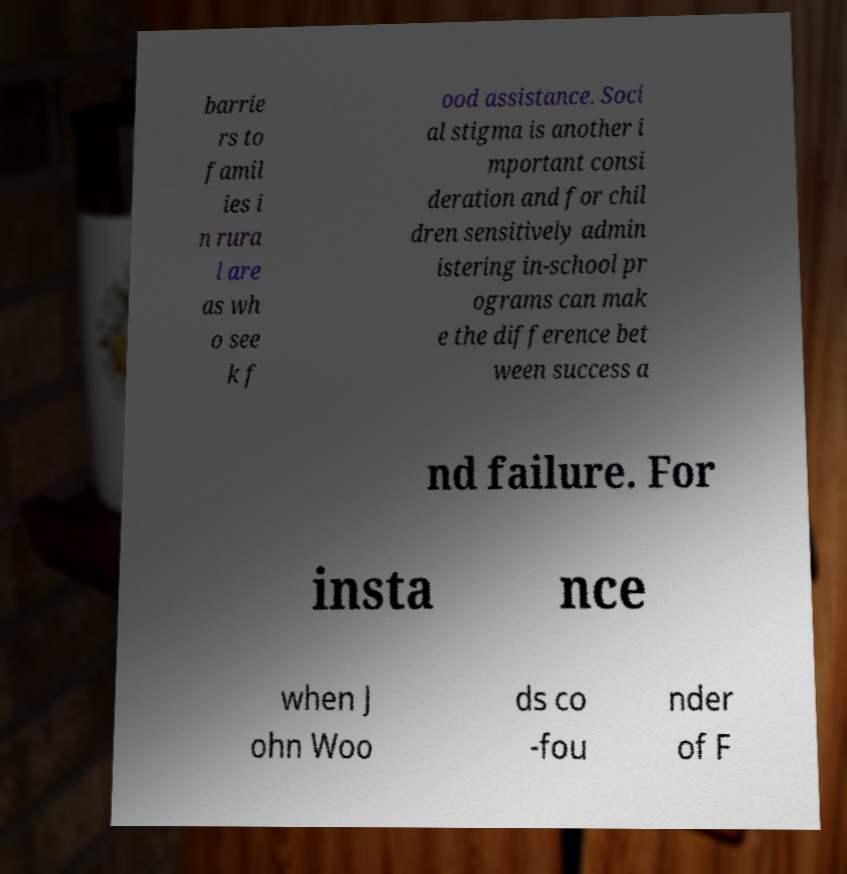For documentation purposes, I need the text within this image transcribed. Could you provide that? barrie rs to famil ies i n rura l are as wh o see k f ood assistance. Soci al stigma is another i mportant consi deration and for chil dren sensitively admin istering in-school pr ograms can mak e the difference bet ween success a nd failure. For insta nce when J ohn Woo ds co -fou nder of F 